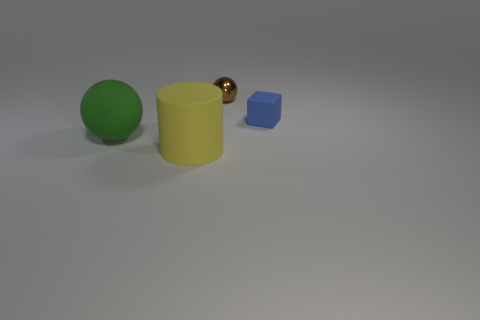The large thing that is to the right of the sphere that is left of the small brown metal sphere is made of what material?
Keep it short and to the point. Rubber. Are there more cylinders left of the tiny rubber block than big blue rubber balls?
Your answer should be very brief. Yes. What number of other objects are there of the same size as the metallic sphere?
Offer a terse response. 1. What is the color of the ball that is behind the object to the right of the shiny object behind the big rubber cylinder?
Ensure brevity in your answer.  Brown. What number of big spheres are behind the ball in front of the small thing that is in front of the tiny sphere?
Keep it short and to the point. 0. Is the size of the sphere that is in front of the block the same as the large matte cylinder?
Offer a terse response. Yes. There is a big object right of the large green rubber ball; what number of large green matte things are behind it?
Your answer should be very brief. 1. Is there a metallic object that is in front of the sphere that is in front of the tiny thing right of the tiny brown metal object?
Give a very brief answer. No. There is another large object that is the same shape as the brown object; what material is it?
Offer a very short reply. Rubber. Is there anything else that has the same material as the brown thing?
Provide a short and direct response. No. 